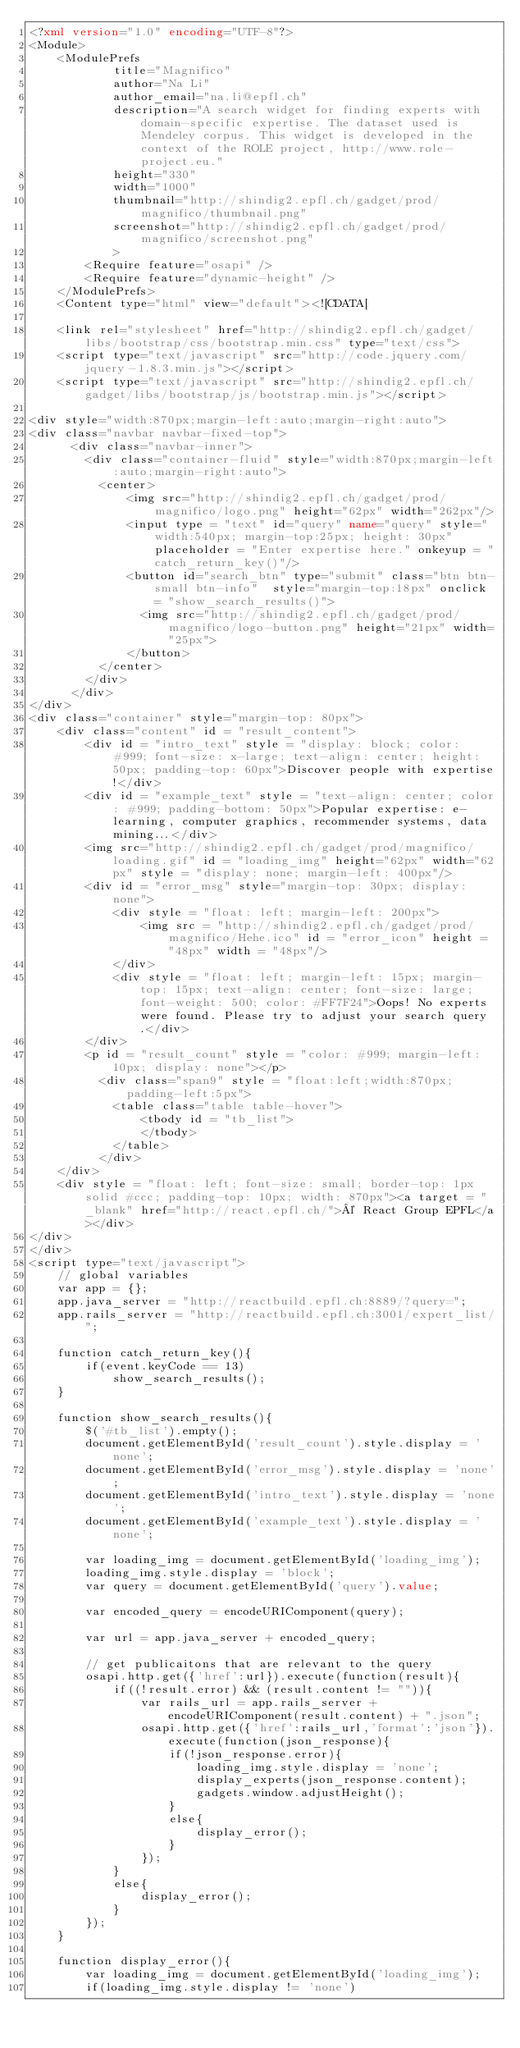Convert code to text. <code><loc_0><loc_0><loc_500><loc_500><_XML_><?xml version="1.0" encoding="UTF-8"?>
<Module>
    <ModulePrefs
            title="Magnifico"
            author="Na Li"
            author_email="na.li@epfl.ch"
            description="A search widget for finding experts with domain-specific expertise. The dataset used is Mendeley corpus. This widget is developed in the context of the ROLE project, http://www.role-project.eu."
            height="330"
            width="1000"
			thumbnail="http://shindig2.epfl.ch/gadget/prod/magnifico/thumbnail.png"
			screenshot="http://shindig2.epfl.ch/gadget/prod/magnifico/screenshot.png"
            >
        <Require feature="osapi" />
        <Require feature="dynamic-height" />
    </ModulePrefs>
    <Content type="html" view="default"><![CDATA[
   	
	<link rel="stylesheet" href="http://shindig2.epfl.ch/gadget/libs/bootstrap/css/bootstrap.min.css" type="text/css">
	<script type="text/javascript" src="http://code.jquery.com/jquery-1.8.3.min.js"></script>
	<script type="text/javascript" src="http://shindig2.epfl.ch/gadget/libs/bootstrap/js/bootstrap.min.js"></script>

<div style="width:870px;margin-left:auto;margin-right:auto">
<div class="navbar navbar-fixed-top">
	  <div class="navbar-inner">
	    <div class="container-fluid" style="width:870px;margin-left:auto;margin-right:auto">
		  <center>
			  <img src="http://shindig2.epfl.ch/gadget/prod/magnifico/logo.png" height="62px" width="262px"/>
			  <input type = "text" id="query" name="query" style="width:540px; margin-top:25px; height: 30px" placeholder = "Enter expertise here." onkeyup = "catch_return_key()"/>
			  <button id="search_btn" type="submit" class="btn btn-small btn-info"  style="margin-top:18px" onclick = "show_search_results()">
				<img src="http://shindig2.epfl.ch/gadget/prod/magnifico/logo-button.png" height="21px" width="25px">
			  </button>
		  </center>
	    </div>
	  </div>
</div>
<div class="container" style="margin-top: 80px">
    <div class="content" id = "result_content">
    	<div id = "intro_text" style = "display: block; color: #999; font-size: x-large; text-align: center; height: 50px; padding-top: 60px">Discover people with expertise!</div>
    	<div id = "example_text" style = "text-align: center; color: #999; padding-bottom: 50px">Popular expertise: e-learning, computer graphics, recommender systems, data mining...</div>
    	<img src="http://shindig2.epfl.ch/gadget/prod/magnifico/loading.gif" id = "loading_img" height="62px" width="62px" style = "display: none; margin-left: 400px"/>
    	<div id = "error_msg" style="margin-top: 30px; display: none">
    		<div style = "float: left; margin-left: 200px">
    		    <img src = "http://shindig2.epfl.ch/gadget/prod/magnifico/Hehe.ico" id = "error_icon" height = "48px" width = "48px"/>
    		</div>
    		<div style = "float: left; margin-left: 15px; margin-top: 15px; text-align: center; font-size: large; font-weight: 500; color: #FF7F24">Oops! No experts were found. Please try to adjust your search query.</div>
    	</div>
    	<p id = "result_count" style = "color: #999; margin-left: 10px; display: none"></p>
		  <div class="span9" style = "float:left;width:870px;padding-left:5px">
			<table class="table table-hover">
				<tbody id = "tb_list">
				</tbody>
			</table>
		  </div>
	</div>
	<div style = "float: left; font-size: small; border-top: 1px solid #ccc; padding-top: 10px; width: 870px"><a target = "_blank" href="http://react.epfl.ch/">© React Group EPFL</a></div>
</div>
</div>
<script type="text/javascript">
	// global variables
	var app = {};
	app.java_server = "http://reactbuild.epfl.ch:8889/?query=";
	app.rails_server = "http://reactbuild.epfl.ch:3001/expert_list/";

	function catch_return_key(){
		if(event.keyCode == 13)
			show_search_results();
	}

	function show_search_results(){
		$('#tb_list').empty();
		document.getElementById('result_count').style.display = 'none';
		document.getElementById('error_msg').style.display = 'none';
		document.getElementById('intro_text').style.display = 'none';
		document.getElementById('example_text').style.display = 'none';
		
		var loading_img = document.getElementById('loading_img');
		loading_img.style.display = 'block';
		var query = document.getElementById('query').value;

		var encoded_query = encodeURIComponent(query);

		var url = app.java_server + encoded_query;

		// get publicaitons that are relevant to the query
		osapi.http.get({'href':url}).execute(function(result){
			if((!result.error) && (result.content != "")){
				var rails_url = app.rails_server + encodeURIComponent(result.content) + ".json";
				osapi.http.get({'href':rails_url,'format':'json'}).execute(function(json_response){
					if(!json_response.error){
						loading_img.style.display = 'none';
						display_experts(json_response.content);
						gadgets.window.adjustHeight();
					}
					else{
						display_error();
					}
				});
			}
			else{
				display_error();
			}
		});
	}

	function display_error(){
		var loading_img = document.getElementById('loading_img');
		if(loading_img.style.display != 'none')</code> 